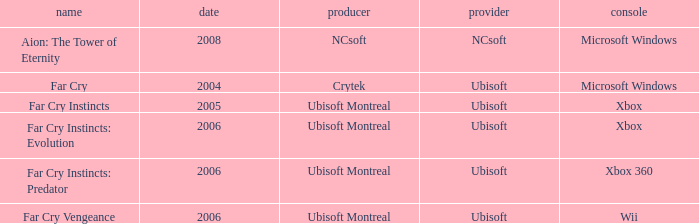Which developer has xbox 360 as the platform? Ubisoft Montreal. 